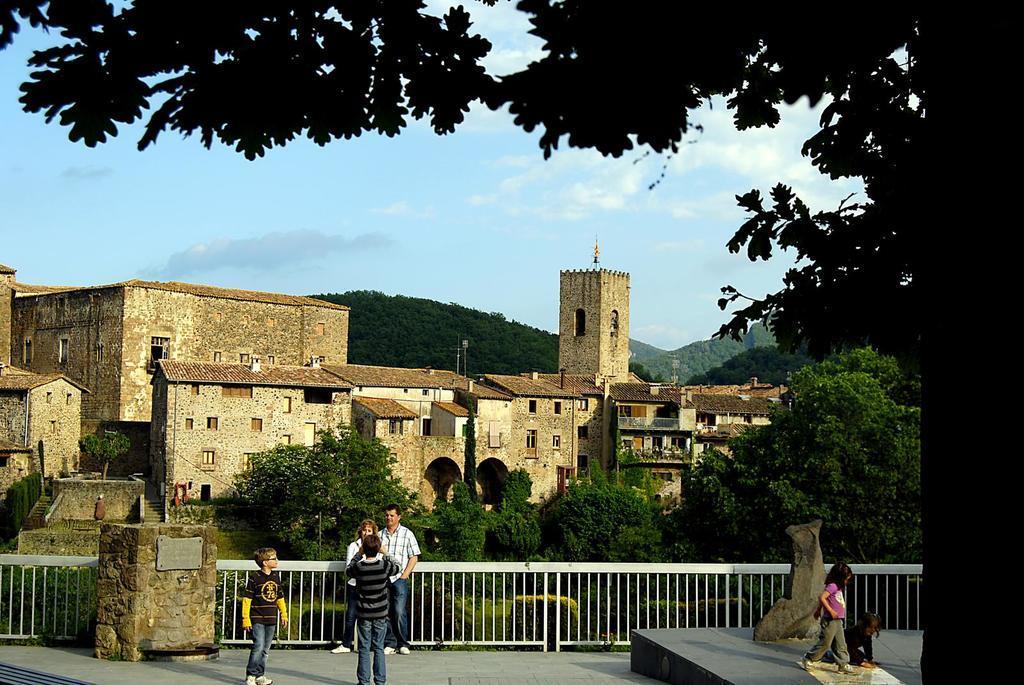Can you describe this image briefly? In this image I can see number of people are standing. In the background I can see number of trees, buildings, mountains, clouds and the sky. 